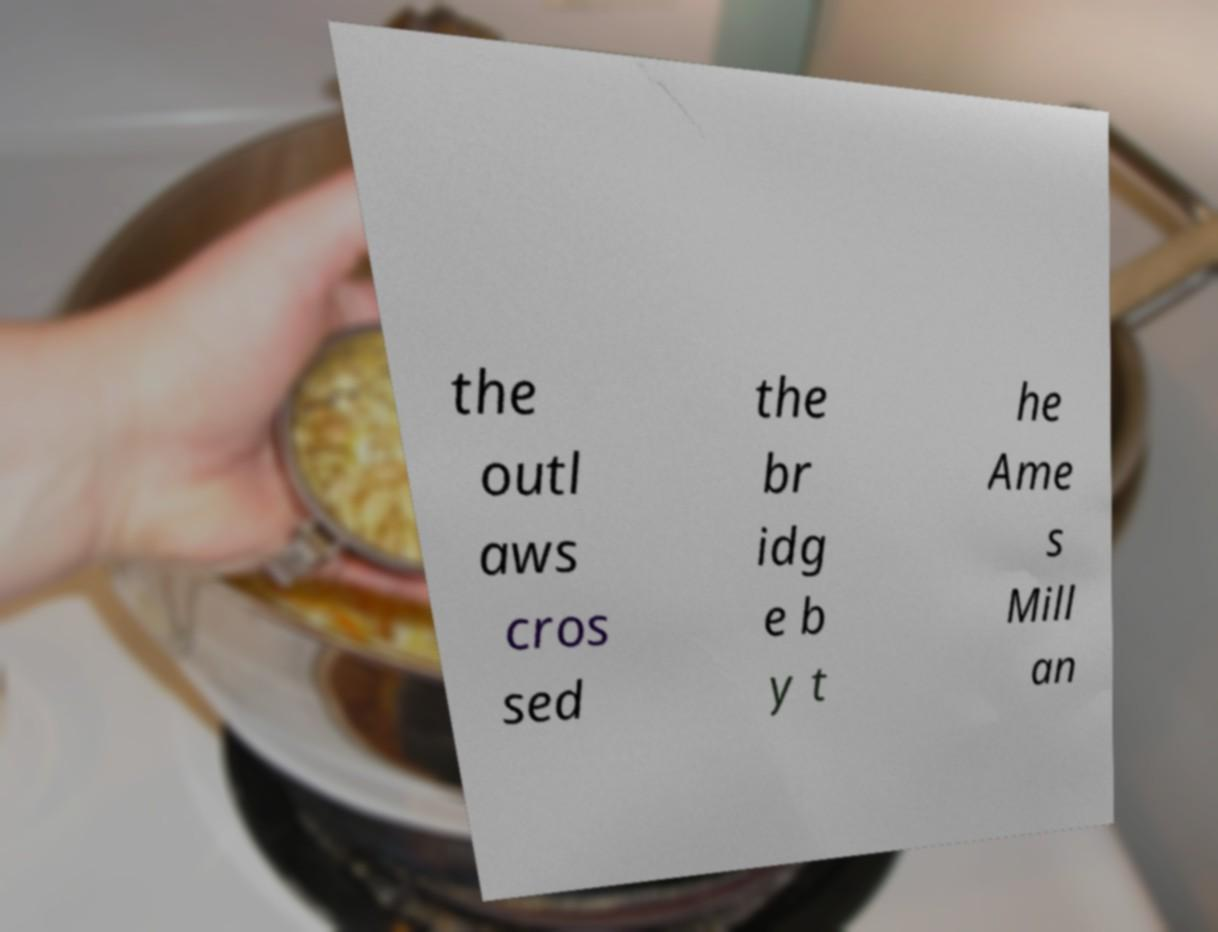Could you extract and type out the text from this image? the outl aws cros sed the br idg e b y t he Ame s Mill an 